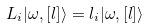<formula> <loc_0><loc_0><loc_500><loc_500>L _ { i } | \omega , [ { l } ] \rangle = l _ { i } | \omega , [ { l } ] \rangle</formula> 